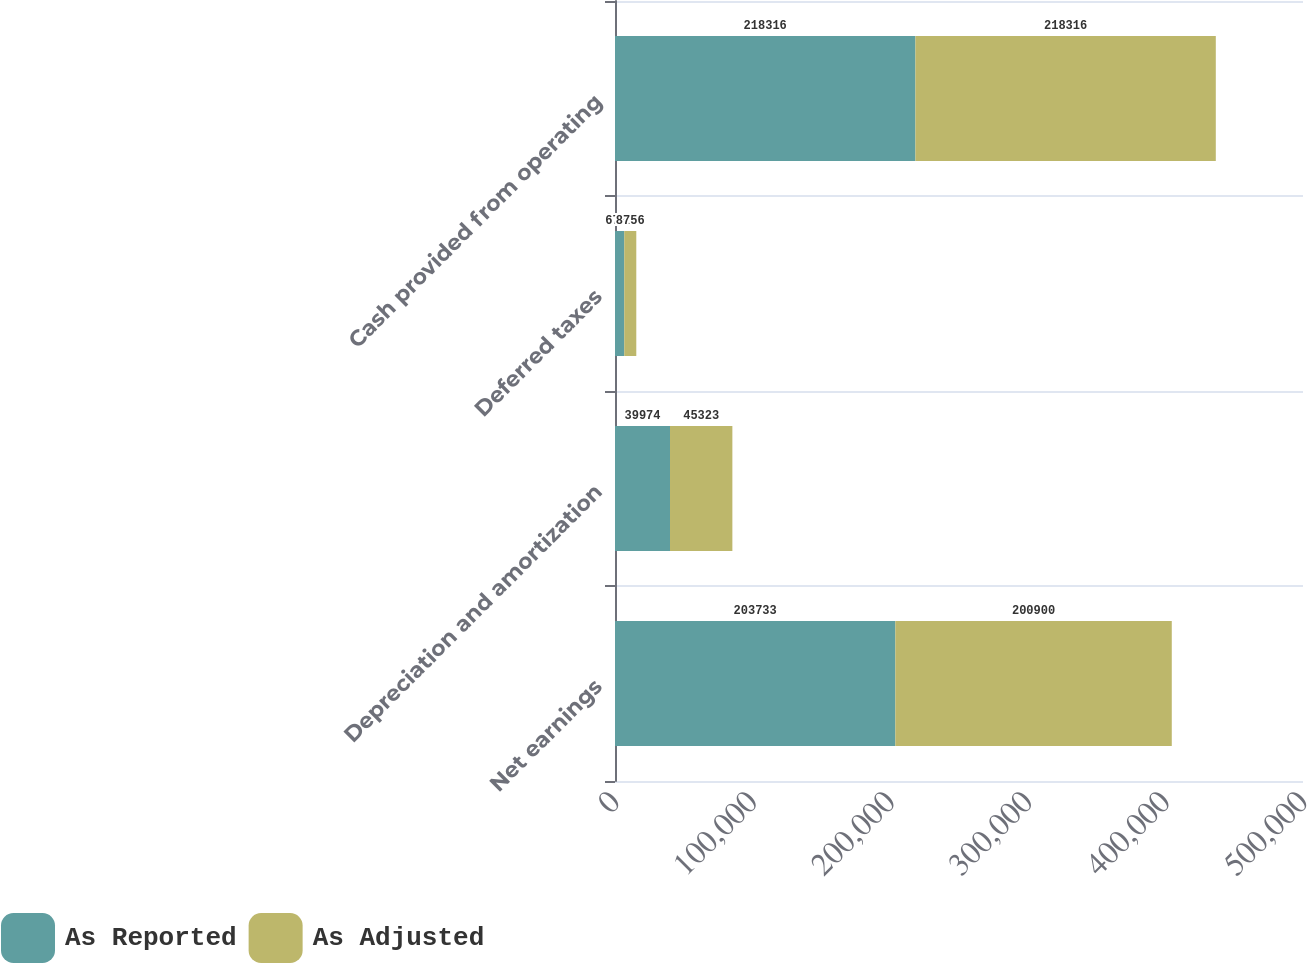Convert chart. <chart><loc_0><loc_0><loc_500><loc_500><stacked_bar_chart><ecel><fcel>Net earnings<fcel>Depreciation and amortization<fcel>Deferred taxes<fcel>Cash provided from operating<nl><fcel>As Reported<fcel>203733<fcel>39974<fcel>6721<fcel>218316<nl><fcel>As Adjusted<fcel>200900<fcel>45323<fcel>8756<fcel>218316<nl></chart> 